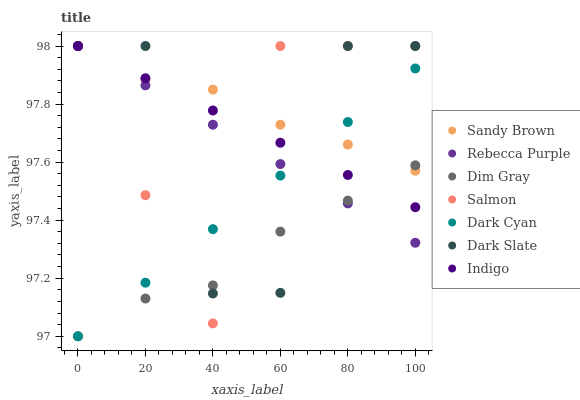Does Dim Gray have the minimum area under the curve?
Answer yes or no. Yes. Does Sandy Brown have the maximum area under the curve?
Answer yes or no. Yes. Does Indigo have the minimum area under the curve?
Answer yes or no. No. Does Indigo have the maximum area under the curve?
Answer yes or no. No. Is Indigo the smoothest?
Answer yes or no. Yes. Is Dark Slate the roughest?
Answer yes or no. Yes. Is Salmon the smoothest?
Answer yes or no. No. Is Salmon the roughest?
Answer yes or no. No. Does Dim Gray have the lowest value?
Answer yes or no. Yes. Does Indigo have the lowest value?
Answer yes or no. No. Does Sandy Brown have the highest value?
Answer yes or no. Yes. Does Dark Cyan have the highest value?
Answer yes or no. No. Does Dark Cyan intersect Salmon?
Answer yes or no. Yes. Is Dark Cyan less than Salmon?
Answer yes or no. No. Is Dark Cyan greater than Salmon?
Answer yes or no. No. 